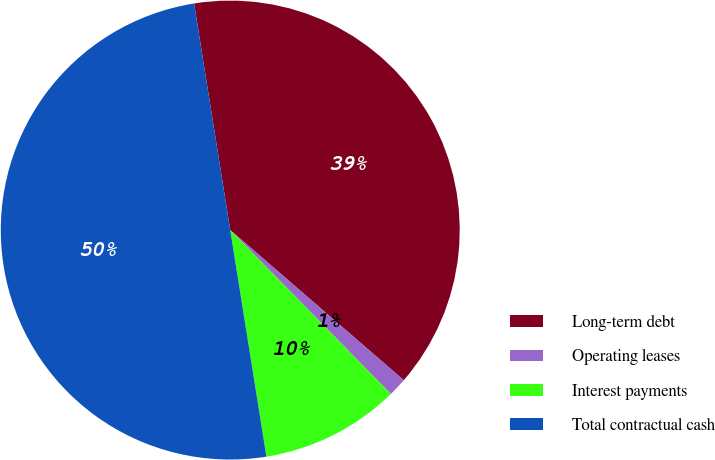<chart> <loc_0><loc_0><loc_500><loc_500><pie_chart><fcel>Long-term debt<fcel>Operating leases<fcel>Interest payments<fcel>Total contractual cash<nl><fcel>38.87%<fcel>1.31%<fcel>9.82%<fcel>50.0%<nl></chart> 